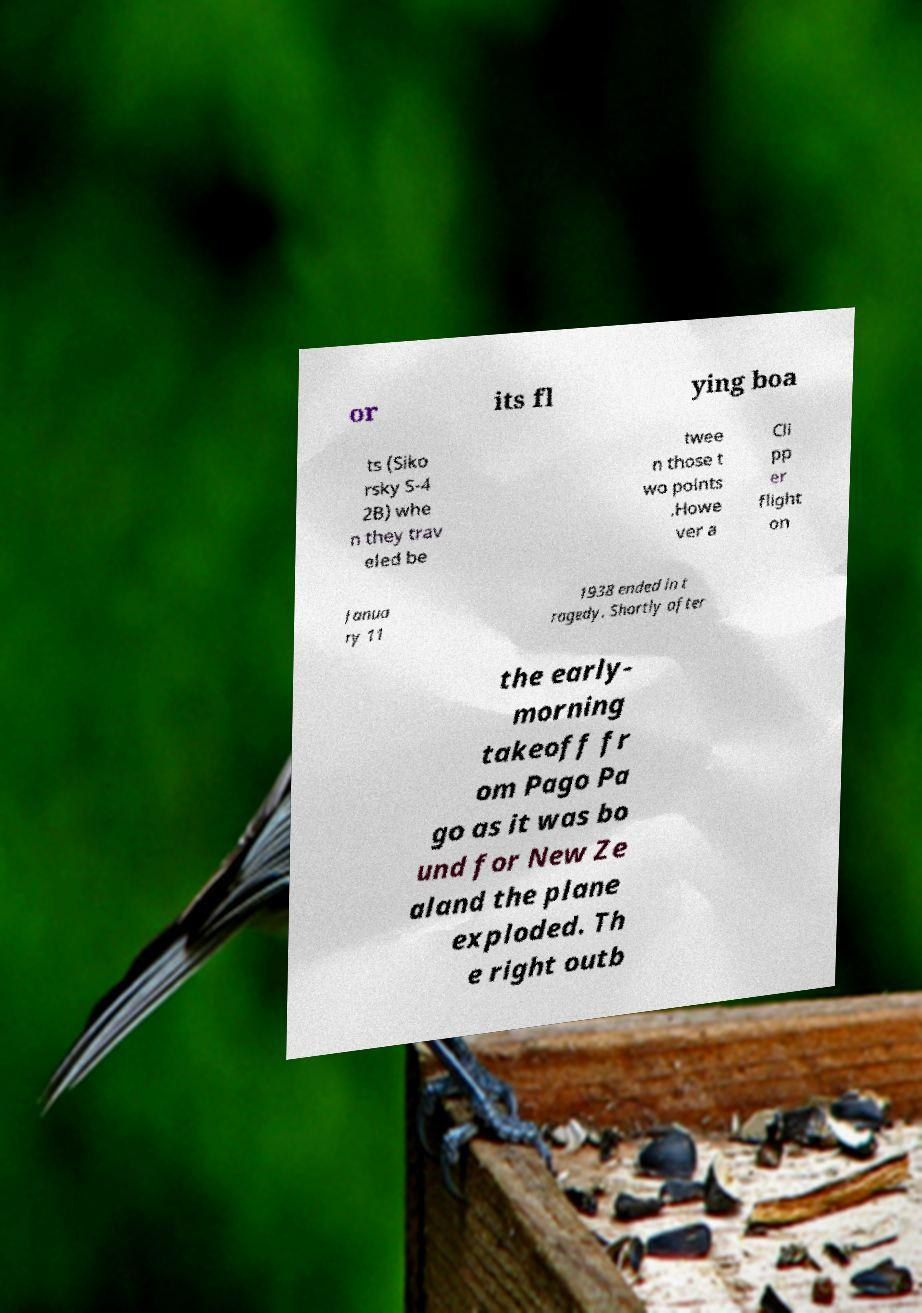Please identify and transcribe the text found in this image. or its fl ying boa ts (Siko rsky S-4 2B) whe n they trav eled be twee n those t wo points .Howe ver a Cli pp er flight on Janua ry 11 1938 ended in t ragedy. Shortly after the early- morning takeoff fr om Pago Pa go as it was bo und for New Ze aland the plane exploded. Th e right outb 